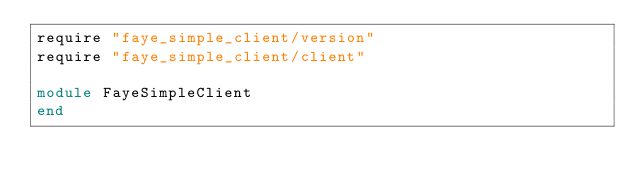Convert code to text. <code><loc_0><loc_0><loc_500><loc_500><_Ruby_>require "faye_simple_client/version"
require "faye_simple_client/client"

module FayeSimpleClient
end
</code> 